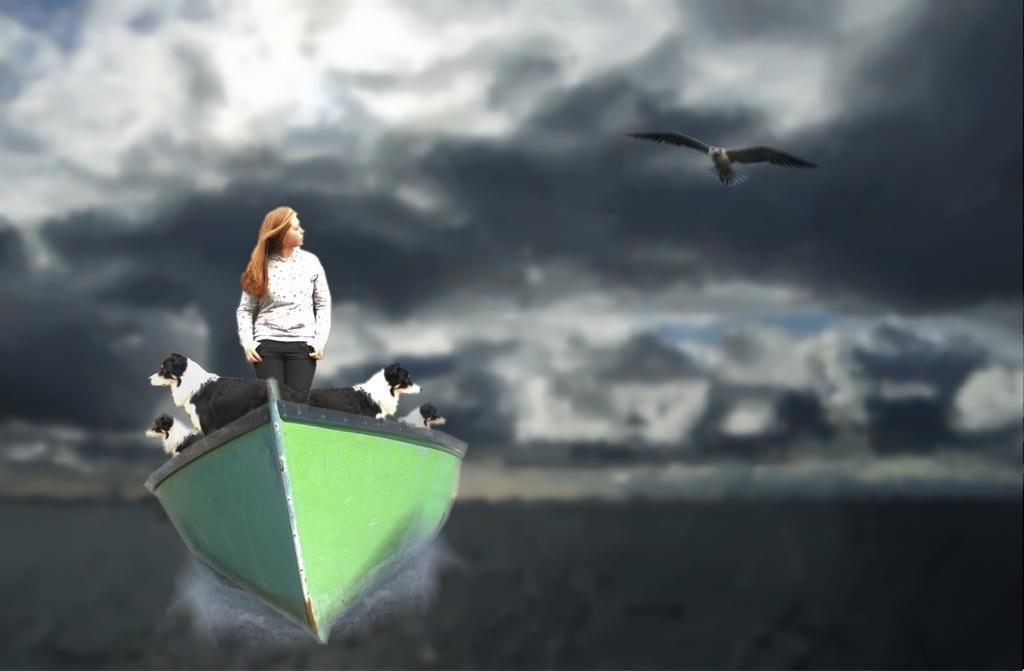What editing technique has been applied to the image? The image is edited. What type of animal can be seen flying in the image? There is a bird flying in the image. How many dogs are present in the image? There are four dogs in the image. What is the woman doing in the image? The woman is standing on a boat in the image. Where is the boat located in the image? The boat is on the water in the image. What can be seen in the background of the image? The sky is visible in the background of the image. Who is the manager of the dogs in the image? There is no manager present in the image, as it does not depict a dog show or any    similar event. 